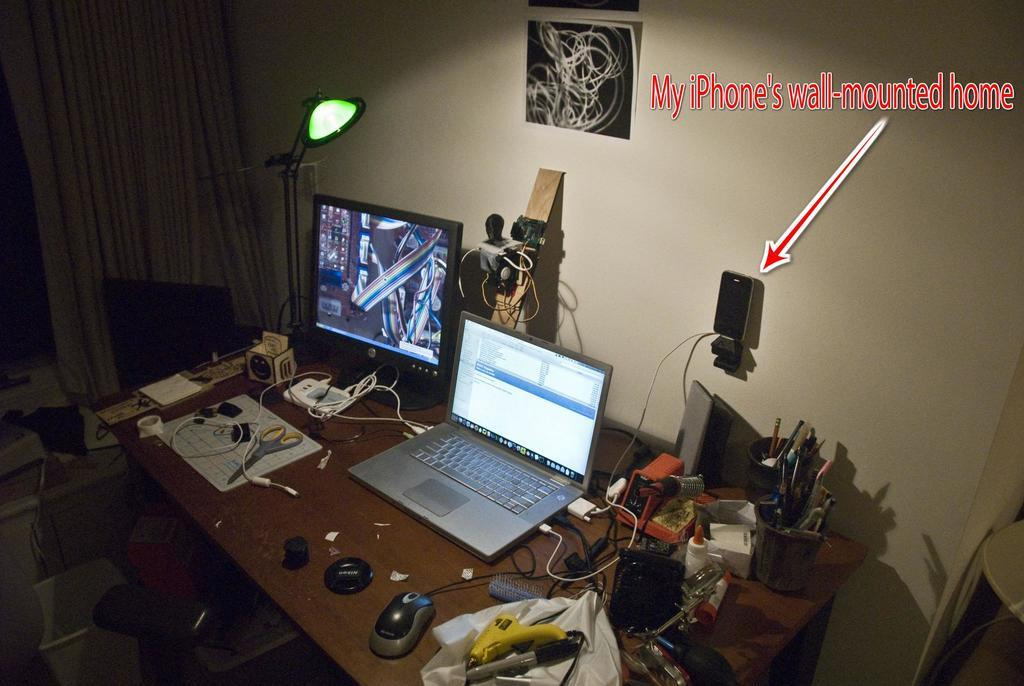Provide a one-sentence caption for the provided image. a home office set up with words IPhone's wall-mounted home. 